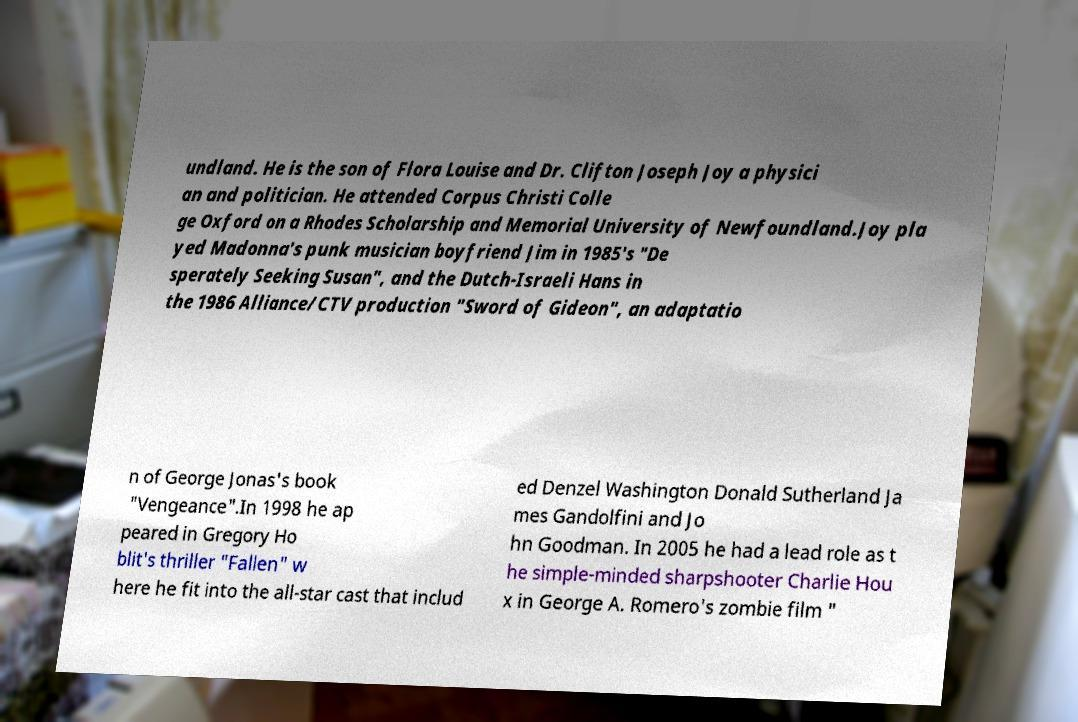What messages or text are displayed in this image? I need them in a readable, typed format. undland. He is the son of Flora Louise and Dr. Clifton Joseph Joy a physici an and politician. He attended Corpus Christi Colle ge Oxford on a Rhodes Scholarship and Memorial University of Newfoundland.Joy pla yed Madonna's punk musician boyfriend Jim in 1985's "De sperately Seeking Susan", and the Dutch-Israeli Hans in the 1986 Alliance/CTV production "Sword of Gideon", an adaptatio n of George Jonas's book "Vengeance".In 1998 he ap peared in Gregory Ho blit's thriller "Fallen" w here he fit into the all-star cast that includ ed Denzel Washington Donald Sutherland Ja mes Gandolfini and Jo hn Goodman. In 2005 he had a lead role as t he simple-minded sharpshooter Charlie Hou x in George A. Romero's zombie film " 